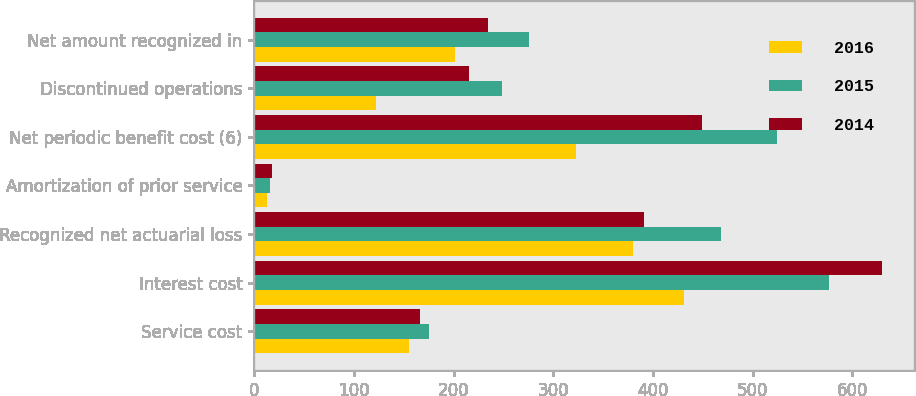Convert chart to OTSL. <chart><loc_0><loc_0><loc_500><loc_500><stacked_bar_chart><ecel><fcel>Service cost<fcel>Interest cost<fcel>Recognized net actuarial loss<fcel>Amortization of prior service<fcel>Net periodic benefit cost (6)<fcel>Discontinued operations<fcel>Net amount recognized in<nl><fcel>2016<fcel>155<fcel>431<fcel>380<fcel>13<fcel>323<fcel>122<fcel>201<nl><fcel>2015<fcel>175<fcel>577<fcel>468<fcel>16<fcel>524<fcel>248<fcel>276<nl><fcel>2014<fcel>166<fcel>630<fcel>391<fcel>18<fcel>449<fcel>215<fcel>234<nl></chart> 